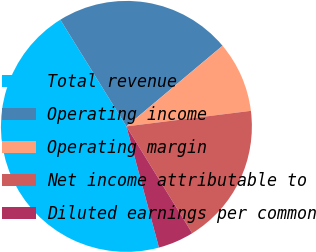Convert chart to OTSL. <chart><loc_0><loc_0><loc_500><loc_500><pie_chart><fcel>Total revenue<fcel>Operating income<fcel>Operating margin<fcel>Net income attributable to<fcel>Diluted earnings per common<nl><fcel>45.35%<fcel>22.72%<fcel>9.13%<fcel>18.19%<fcel>4.61%<nl></chart> 